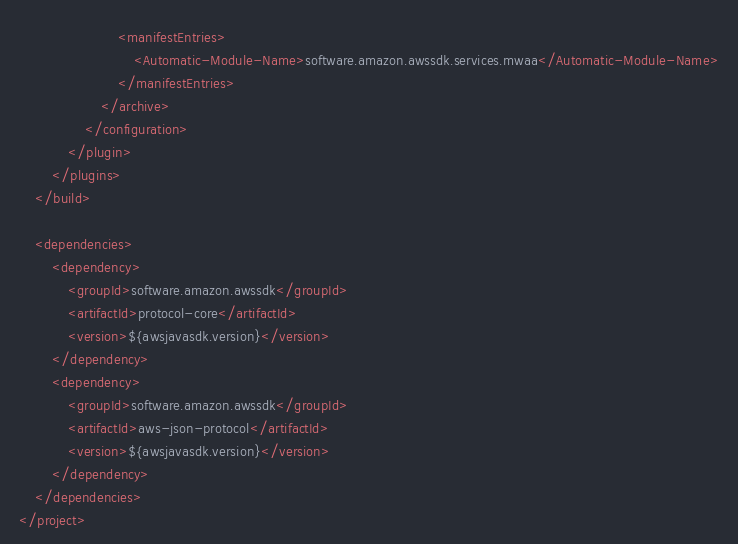<code> <loc_0><loc_0><loc_500><loc_500><_XML_>                        <manifestEntries>
                            <Automatic-Module-Name>software.amazon.awssdk.services.mwaa</Automatic-Module-Name>
                        </manifestEntries>
                    </archive>
                </configuration>
            </plugin>
        </plugins>
    </build>

    <dependencies>
        <dependency>
            <groupId>software.amazon.awssdk</groupId>
            <artifactId>protocol-core</artifactId>
            <version>${awsjavasdk.version}</version>
        </dependency>
        <dependency>
            <groupId>software.amazon.awssdk</groupId>
            <artifactId>aws-json-protocol</artifactId>
            <version>${awsjavasdk.version}</version>
        </dependency>
    </dependencies>
</project>
</code> 